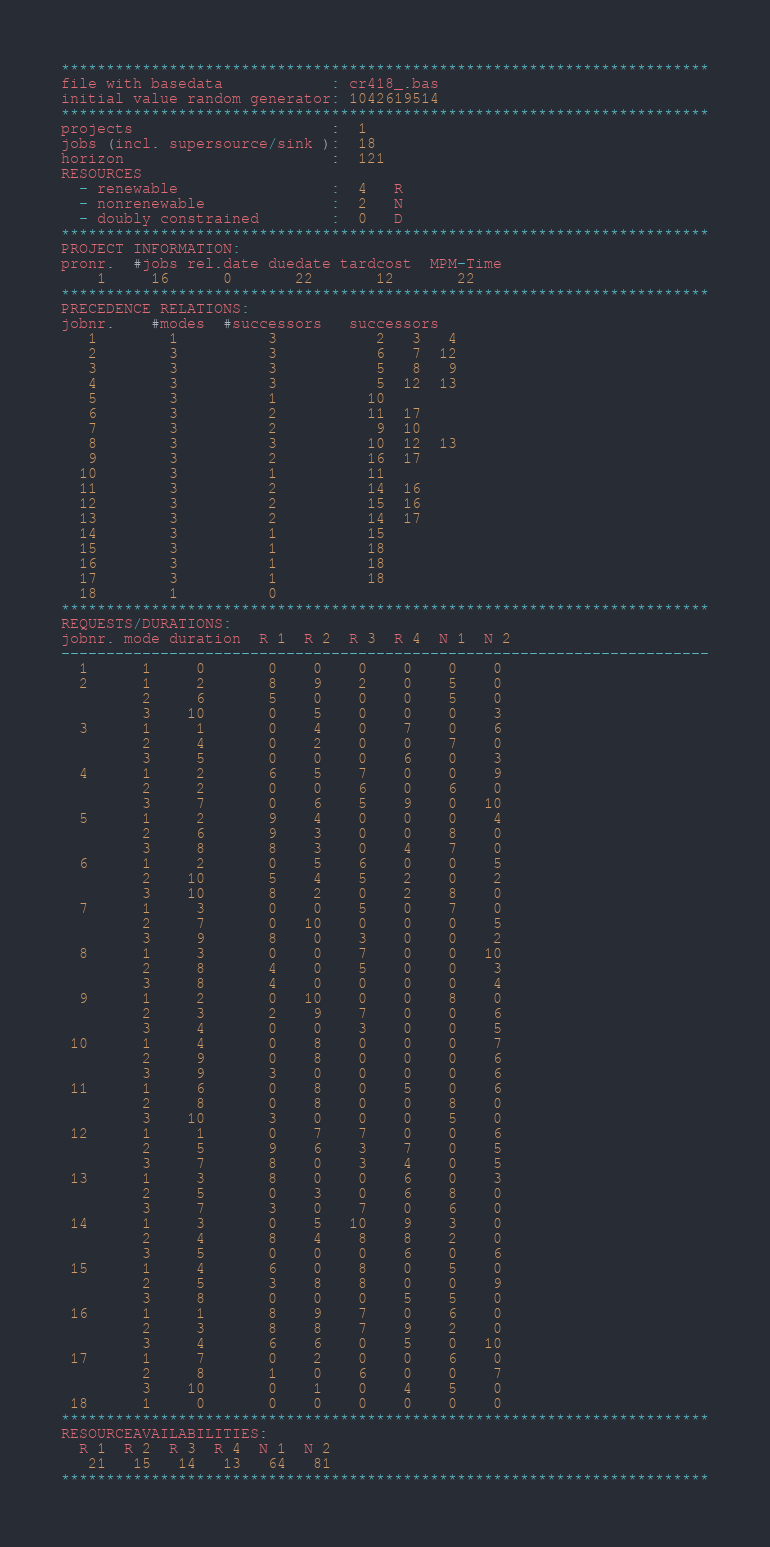Convert code to text. <code><loc_0><loc_0><loc_500><loc_500><_ObjectiveC_>************************************************************************
file with basedata            : cr418_.bas
initial value random generator: 1042619514
************************************************************************
projects                      :  1
jobs (incl. supersource/sink ):  18
horizon                       :  121
RESOURCES
  - renewable                 :  4   R
  - nonrenewable              :  2   N
  - doubly constrained        :  0   D
************************************************************************
PROJECT INFORMATION:
pronr.  #jobs rel.date duedate tardcost  MPM-Time
    1     16      0       22       12       22
************************************************************************
PRECEDENCE RELATIONS:
jobnr.    #modes  #successors   successors
   1        1          3           2   3   4
   2        3          3           6   7  12
   3        3          3           5   8   9
   4        3          3           5  12  13
   5        3          1          10
   6        3          2          11  17
   7        3          2           9  10
   8        3          3          10  12  13
   9        3          2          16  17
  10        3          1          11
  11        3          2          14  16
  12        3          2          15  16
  13        3          2          14  17
  14        3          1          15
  15        3          1          18
  16        3          1          18
  17        3          1          18
  18        1          0        
************************************************************************
REQUESTS/DURATIONS:
jobnr. mode duration  R 1  R 2  R 3  R 4  N 1  N 2
------------------------------------------------------------------------
  1      1     0       0    0    0    0    0    0
  2      1     2       8    9    2    0    5    0
         2     6       5    0    0    0    5    0
         3    10       0    5    0    0    0    3
  3      1     1       0    4    0    7    0    6
         2     4       0    2    0    0    7    0
         3     5       0    0    0    6    0    3
  4      1     2       6    5    7    0    0    9
         2     2       0    0    6    0    6    0
         3     7       0    6    5    9    0   10
  5      1     2       9    4    0    0    0    4
         2     6       9    3    0    0    8    0
         3     8       8    3    0    4    7    0
  6      1     2       0    5    6    0    0    5
         2    10       5    4    5    2    0    2
         3    10       8    2    0    2    8    0
  7      1     3       0    0    5    0    7    0
         2     7       0   10    0    0    0    5
         3     9       8    0    3    0    0    2
  8      1     3       0    0    7    0    0   10
         2     8       4    0    5    0    0    3
         3     8       4    0    0    0    0    4
  9      1     2       0   10    0    0    8    0
         2     3       2    9    7    0    0    6
         3     4       0    0    3    0    0    5
 10      1     4       0    8    0    0    0    7
         2     9       0    8    0    0    0    6
         3     9       3    0    0    0    0    6
 11      1     6       0    8    0    5    0    6
         2     8       0    8    0    0    8    0
         3    10       3    0    0    0    5    0
 12      1     1       0    7    7    0    0    6
         2     5       9    6    3    7    0    5
         3     7       8    0    3    4    0    5
 13      1     3       8    0    0    6    0    3
         2     5       0    3    0    6    8    0
         3     7       3    0    7    0    6    0
 14      1     3       0    5   10    9    3    0
         2     4       8    4    8    8    2    0
         3     5       0    0    0    6    0    6
 15      1     4       6    0    8    0    5    0
         2     5       3    8    8    0    0    9
         3     8       0    0    0    5    5    0
 16      1     1       8    9    7    0    6    0
         2     3       8    8    7    9    2    0
         3     4       6    6    0    5    0   10
 17      1     7       0    2    0    0    6    0
         2     8       1    0    6    0    0    7
         3    10       0    1    0    4    5    0
 18      1     0       0    0    0    0    0    0
************************************************************************
RESOURCEAVAILABILITIES:
  R 1  R 2  R 3  R 4  N 1  N 2
   21   15   14   13   64   81
************************************************************************
</code> 